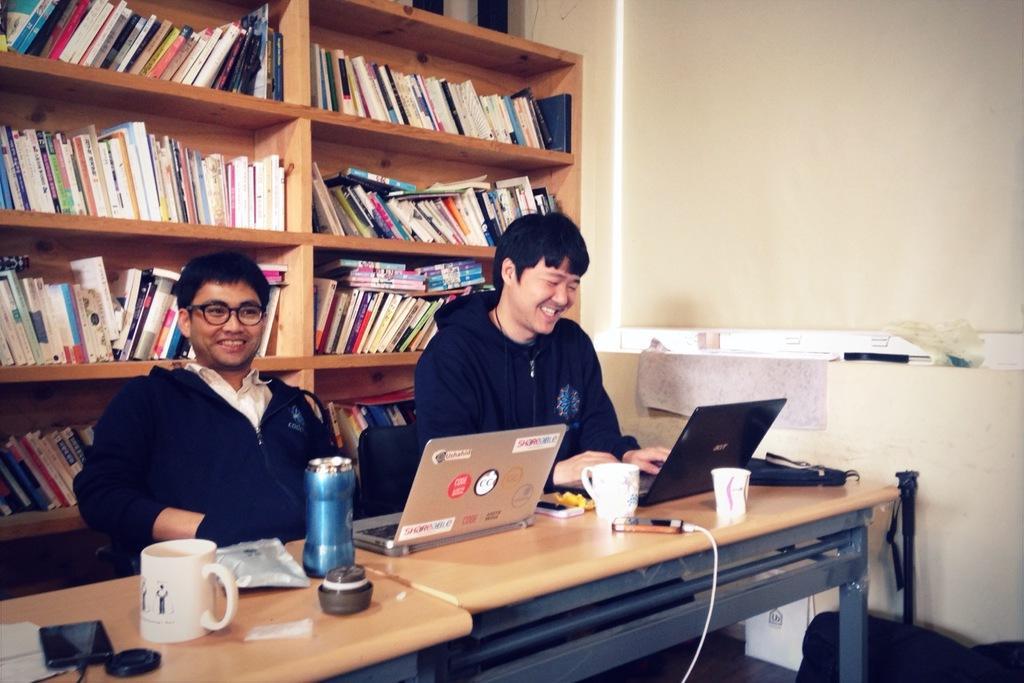How would you summarize this image in a sentence or two? In this image we can see these two men wearing black jackets are sitting on the chairs and smiling. Here we can see mobile phones, laptops, cups and a few more things are kept on the table. In the background, we can see books kept on the shelf. 